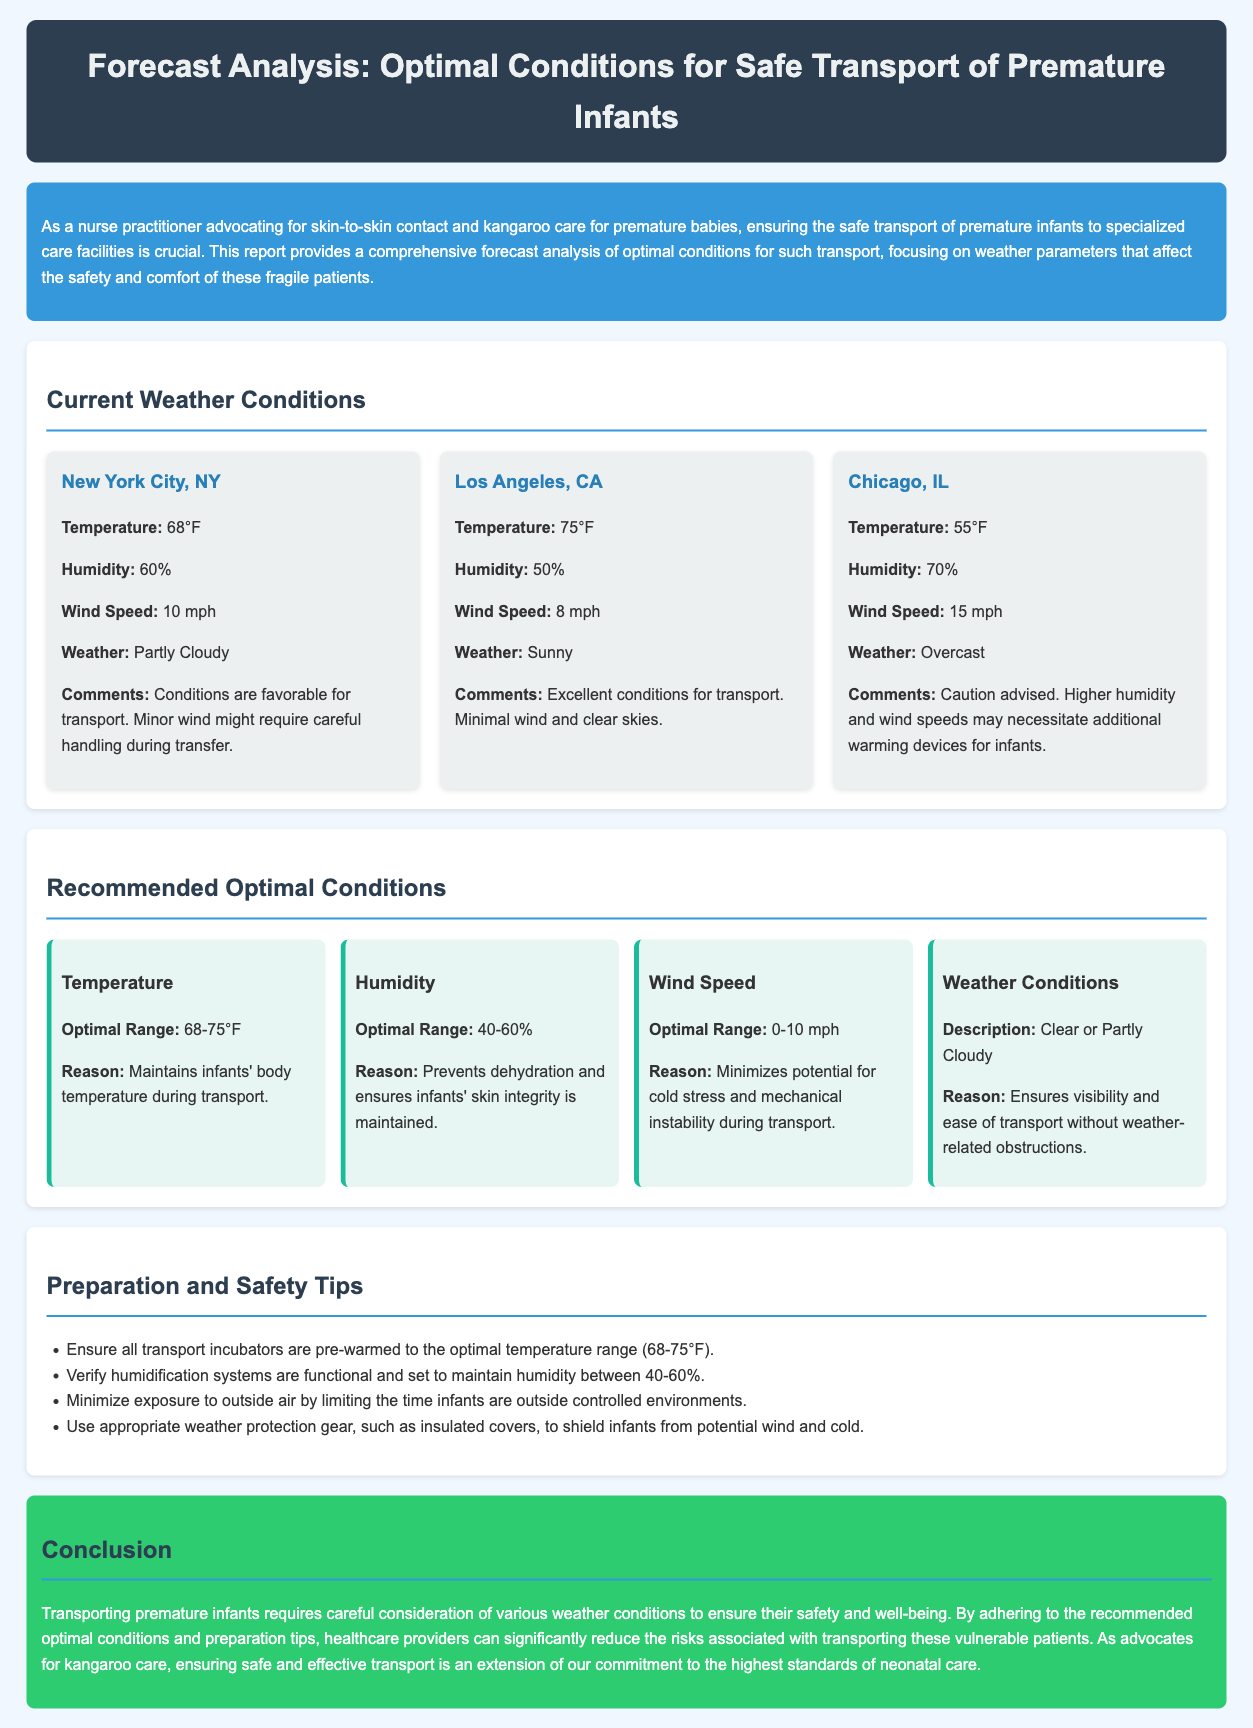what is the optimal temperature range for transporting premature infants? The optimal temperature range is specified in the document to maintain infants' body temperature during transport.
Answer: 68-75°F what is the wind speed in Chicago, IL? The document provides specific weather conditions for different cities, including Chicago's wind speed.
Answer: 15 mph which city has sunny weather conditions? The weather reports for each city clearly describe the current weather, identifying sunny conditions in one.
Answer: Los Angeles, CA what is the reason for maintaining a humidity level between 40-60%? The document explains the rationale behind the recommended humidity range for infant transport.
Answer: Prevents dehydration and ensures infants' skin integrity is maintained what should be the wind speed for optimal transport conditions? The document outlines the optimal conditions for various parameters, including wind speed.
Answer: 0-10 mph what is a safety tip for preparing transport incubators? The document outlines specific preparations for safe transport, including how to handle incubators.
Answer: Ensure all transport incubators are pre-warmed to the optimal temperature range what is the weather condition recommended for transporting infants? The document specifies the preferred weather conditions ideal for safe infant transport.
Answer: Clear or Partly Cloudy what is the humidity level in New York City, NY? The weather condition for New York City in the document includes a specified humidity level.
Answer: 60% 